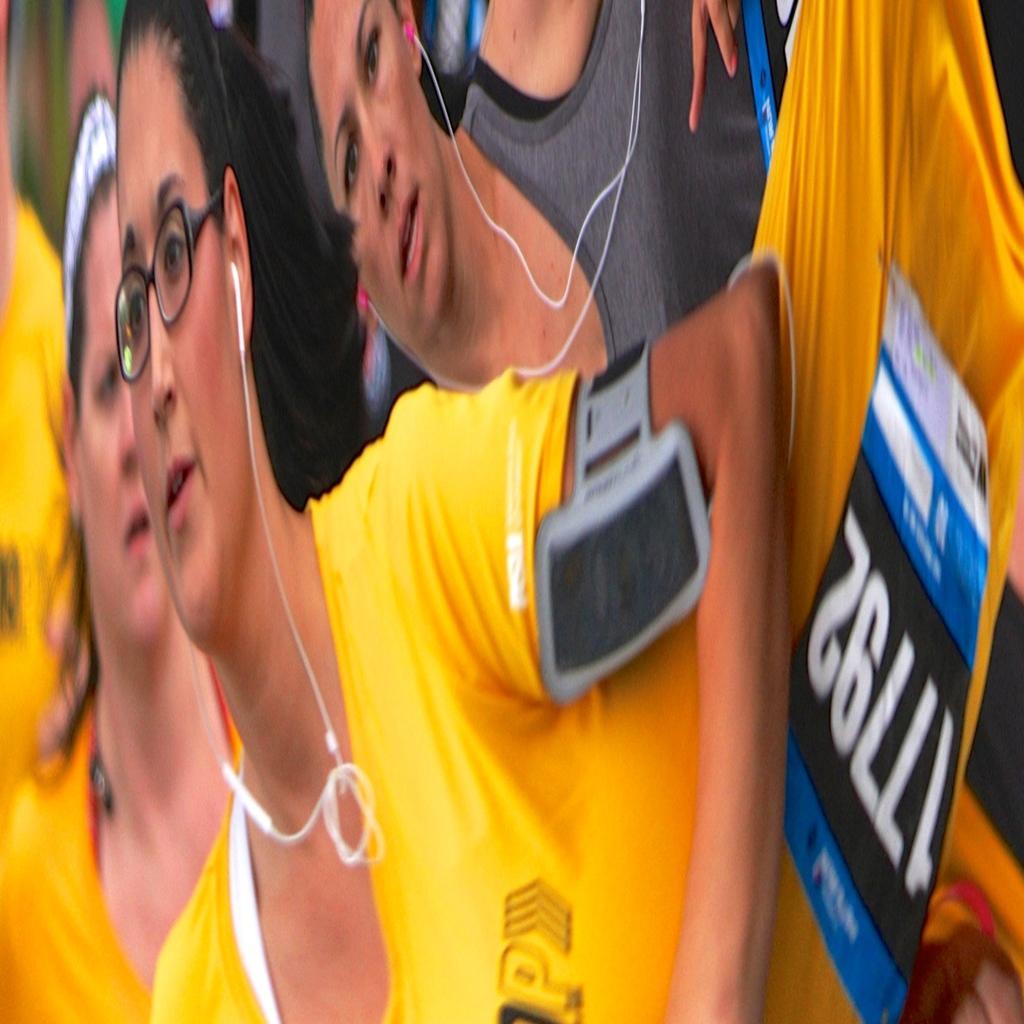Describe this image in one or two sentences. In this image we can see few persons and among them two persons are having headsets to their ears and there is a device on a person´s hand. 